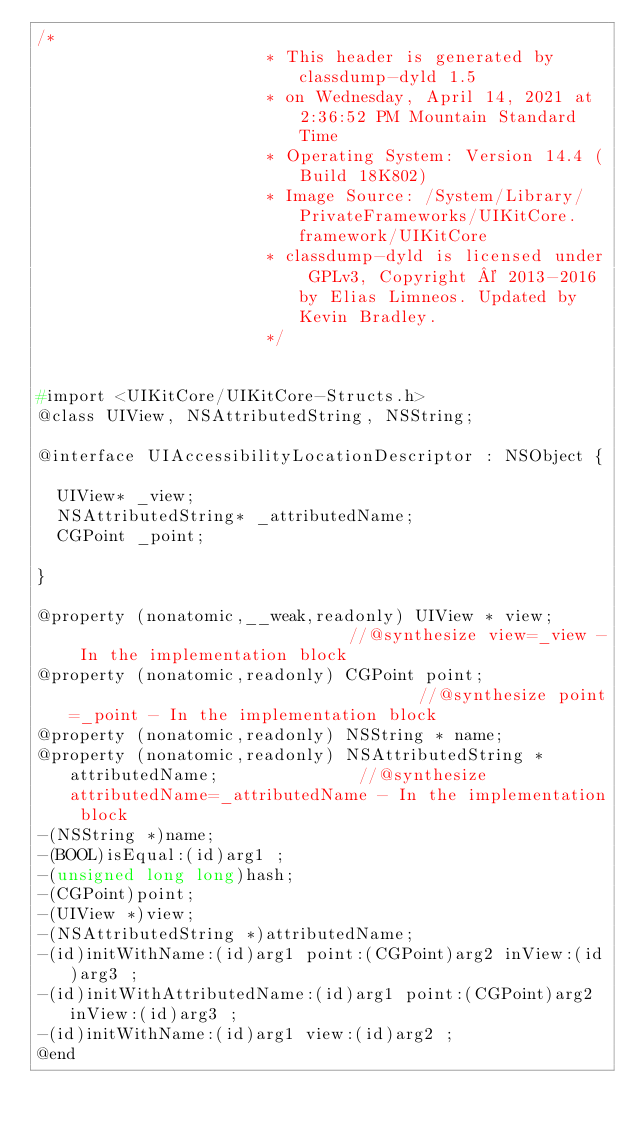<code> <loc_0><loc_0><loc_500><loc_500><_C_>/*
                       * This header is generated by classdump-dyld 1.5
                       * on Wednesday, April 14, 2021 at 2:36:52 PM Mountain Standard Time
                       * Operating System: Version 14.4 (Build 18K802)
                       * Image Source: /System/Library/PrivateFrameworks/UIKitCore.framework/UIKitCore
                       * classdump-dyld is licensed under GPLv3, Copyright © 2013-2016 by Elias Limneos. Updated by Kevin Bradley.
                       */


#import <UIKitCore/UIKitCore-Structs.h>
@class UIView, NSAttributedString, NSString;

@interface UIAccessibilityLocationDescriptor : NSObject {

	UIView* _view;
	NSAttributedString* _attributedName;
	CGPoint _point;

}

@property (nonatomic,__weak,readonly) UIView * view;                             //@synthesize view=_view - In the implementation block
@property (nonatomic,readonly) CGPoint point;                                    //@synthesize point=_point - In the implementation block
@property (nonatomic,readonly) NSString * name; 
@property (nonatomic,readonly) NSAttributedString * attributedName;              //@synthesize attributedName=_attributedName - In the implementation block
-(NSString *)name;
-(BOOL)isEqual:(id)arg1 ;
-(unsigned long long)hash;
-(CGPoint)point;
-(UIView *)view;
-(NSAttributedString *)attributedName;
-(id)initWithName:(id)arg1 point:(CGPoint)arg2 inView:(id)arg3 ;
-(id)initWithAttributedName:(id)arg1 point:(CGPoint)arg2 inView:(id)arg3 ;
-(id)initWithName:(id)arg1 view:(id)arg2 ;
@end

</code> 